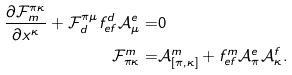Convert formula to latex. <formula><loc_0><loc_0><loc_500><loc_500>\frac { \partial \mathcal { F } _ { m } ^ { \pi \kappa } } { \partial x ^ { \kappa } } + \mathcal { F } _ { d } ^ { \pi \mu } f ^ { d } _ { e f } \mathcal { A } ^ { e } _ { \mu } = & 0 \\ \mathcal { F } ^ { m } _ { \pi \kappa } = & \mathcal { A } ^ { m } _ { [ \pi , \kappa ] } + f ^ { m } _ { e f } \mathcal { A } ^ { e } _ { \pi } \mathcal { A } ^ { f } _ { \kappa } .</formula> 